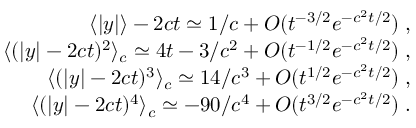Convert formula to latex. <formula><loc_0><loc_0><loc_500><loc_500>\begin{array} { r l r } & { \langle | y | \rangle - 2 c t \simeq 1 / c + O ( t ^ { - 3 / 2 } e ^ { - c ^ { 2 } t / 2 } ) \, , } \\ & { \langle ( | y | - 2 c t ) ^ { 2 } \rangle _ { c } \simeq 4 t - 3 / c ^ { 2 } + O ( t ^ { - 1 / 2 } e ^ { - c ^ { 2 } t / 2 } ) \, , } \\ & { \langle ( | y | - 2 c t ) ^ { 3 } \rangle _ { c } \simeq 1 4 / c ^ { 3 } + O ( t ^ { 1 / 2 } e ^ { - c ^ { 2 } t / 2 } ) \, , } \\ & { \langle ( | y | - 2 c t ) ^ { 4 } \rangle _ { c } \simeq - 9 0 / c ^ { 4 } + O ( t ^ { 3 / 2 } e ^ { - c ^ { 2 } t / 2 } ) \, . } \end{array}</formula> 